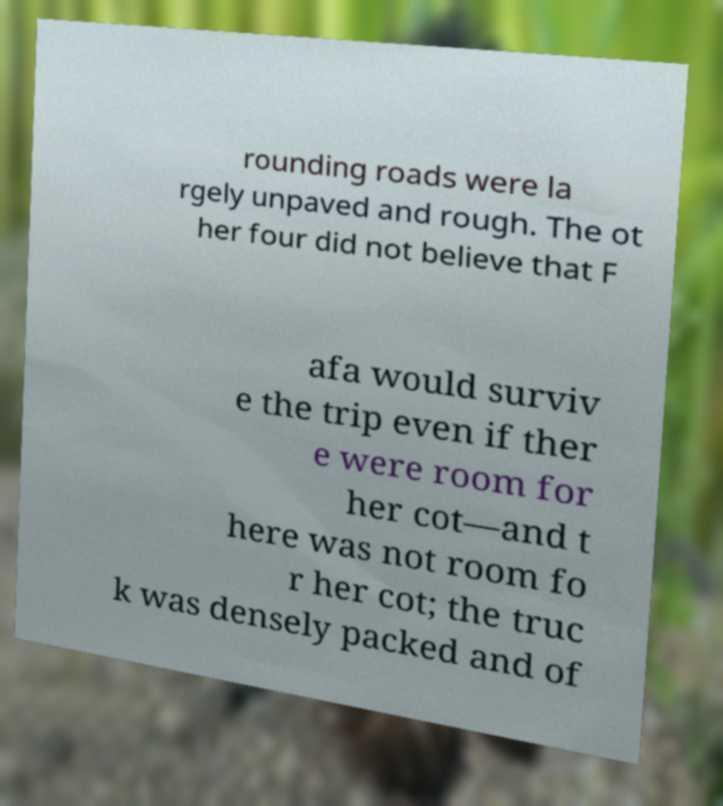Please read and relay the text visible in this image. What does it say? rounding roads were la rgely unpaved and rough. The ot her four did not believe that F afa would surviv e the trip even if ther e were room for her cot—and t here was not room fo r her cot; the truc k was densely packed and of 